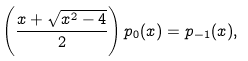<formula> <loc_0><loc_0><loc_500><loc_500>\left ( \frac { x + \sqrt { x ^ { 2 } - 4 } } { 2 } \right ) p _ { 0 } ( x ) = p _ { - 1 } ( x ) ,</formula> 